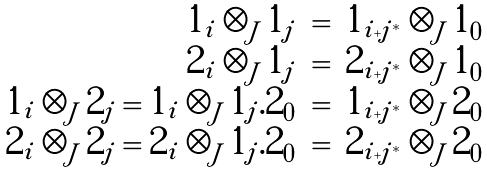Convert formula to latex. <formula><loc_0><loc_0><loc_500><loc_500>\begin{array} { r c l } 1 _ { i } \otimes _ { J } 1 _ { j } & = & 1 _ { i + j ^ { * } } \otimes _ { J } 1 _ { 0 } \\ 2 _ { i } \otimes _ { J } 1 _ { j } & = & 2 _ { i + j ^ { * } } \otimes _ { J } 1 _ { 0 } \\ 1 _ { i } \otimes _ { J } 2 _ { j } = 1 _ { i } \otimes _ { J } 1 _ { j } . 2 _ { 0 } & = & 1 _ { i + j ^ { * } } \otimes _ { J } 2 _ { 0 } \\ 2 _ { i } \otimes _ { J } 2 _ { j } = 2 _ { i } \otimes _ { J } 1 _ { j } . 2 _ { 0 } & = & 2 _ { i + j ^ { * } } \otimes _ { J } 2 _ { 0 } \end{array}</formula> 